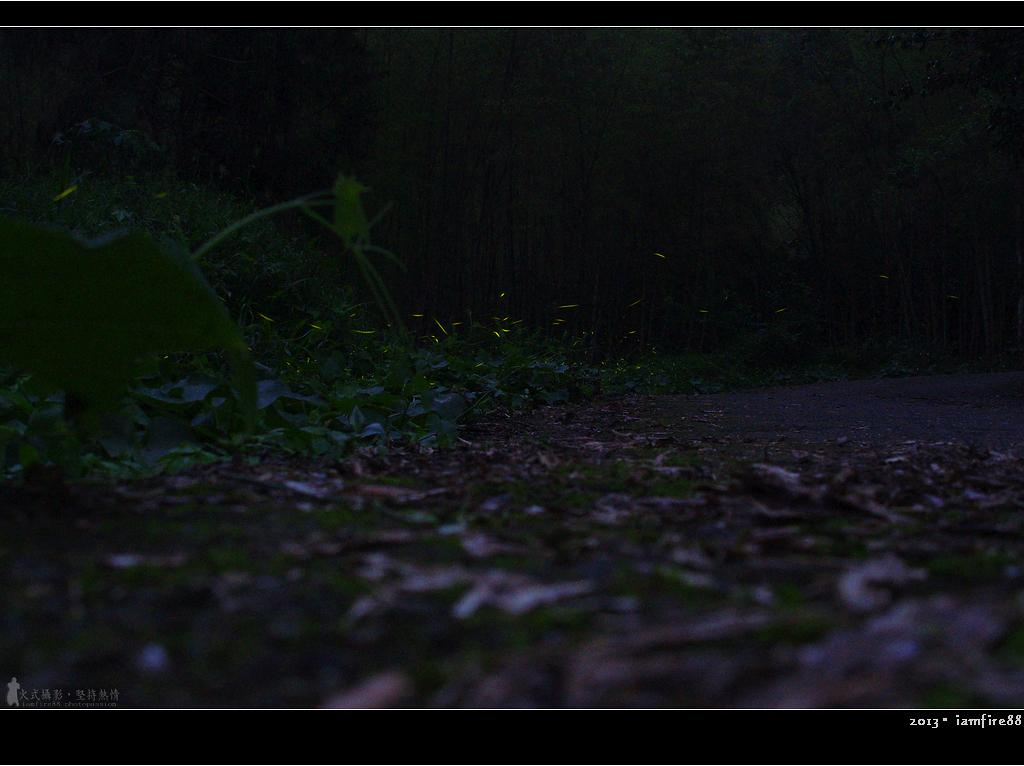What is located in the middle of the picture? There are plants in the middle of the picture. What can be seen on the ground in the image? Dried leaves are present on the ground. What is the color of the background in the image? The background of the image is dark. What type of operation is being performed on the person in the image? There is no person present in the image, and therefore no operation is being performed. What part of the plant is shown in the image? The provided facts do not specify a particular part of the plant; it only mentions that there are plants in the middle of the picture. 